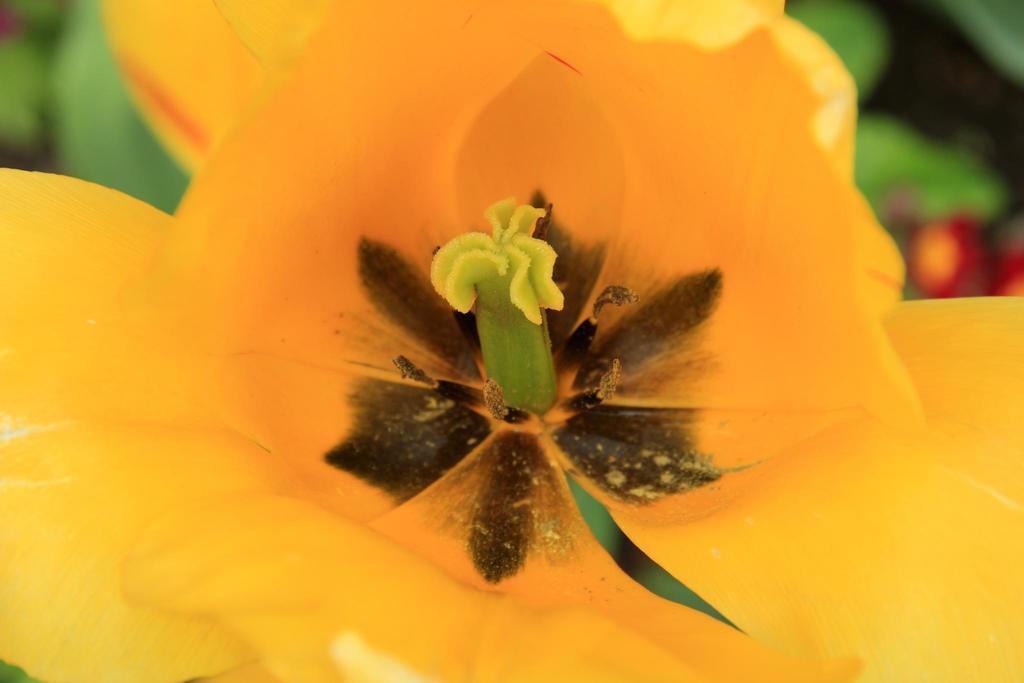Describe this image in one or two sentences. In this image in the front there is a flower and the background is blurry. 